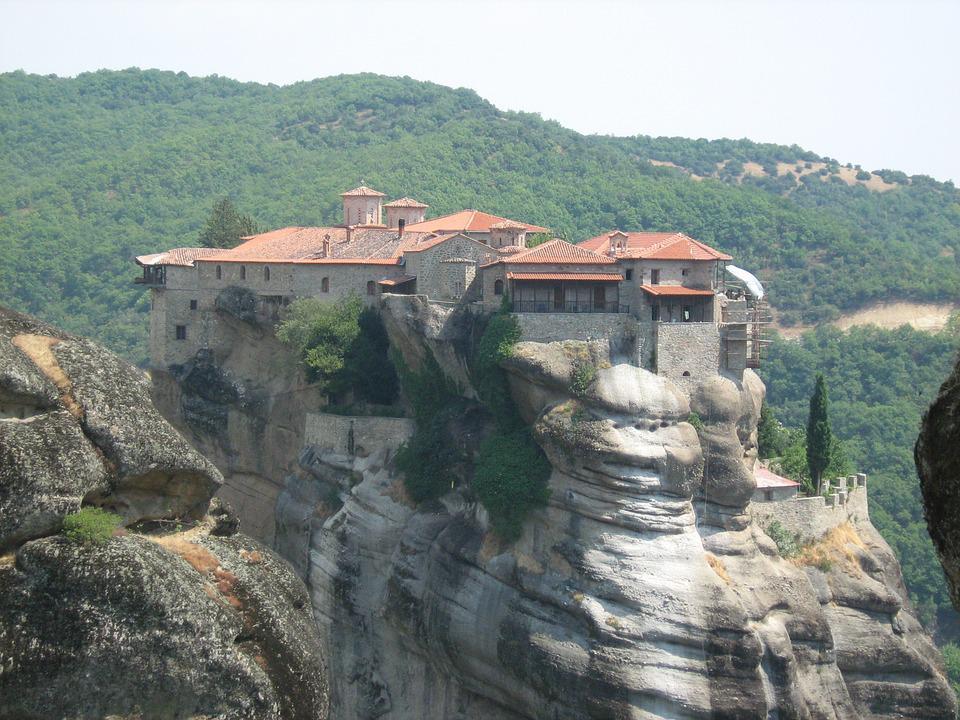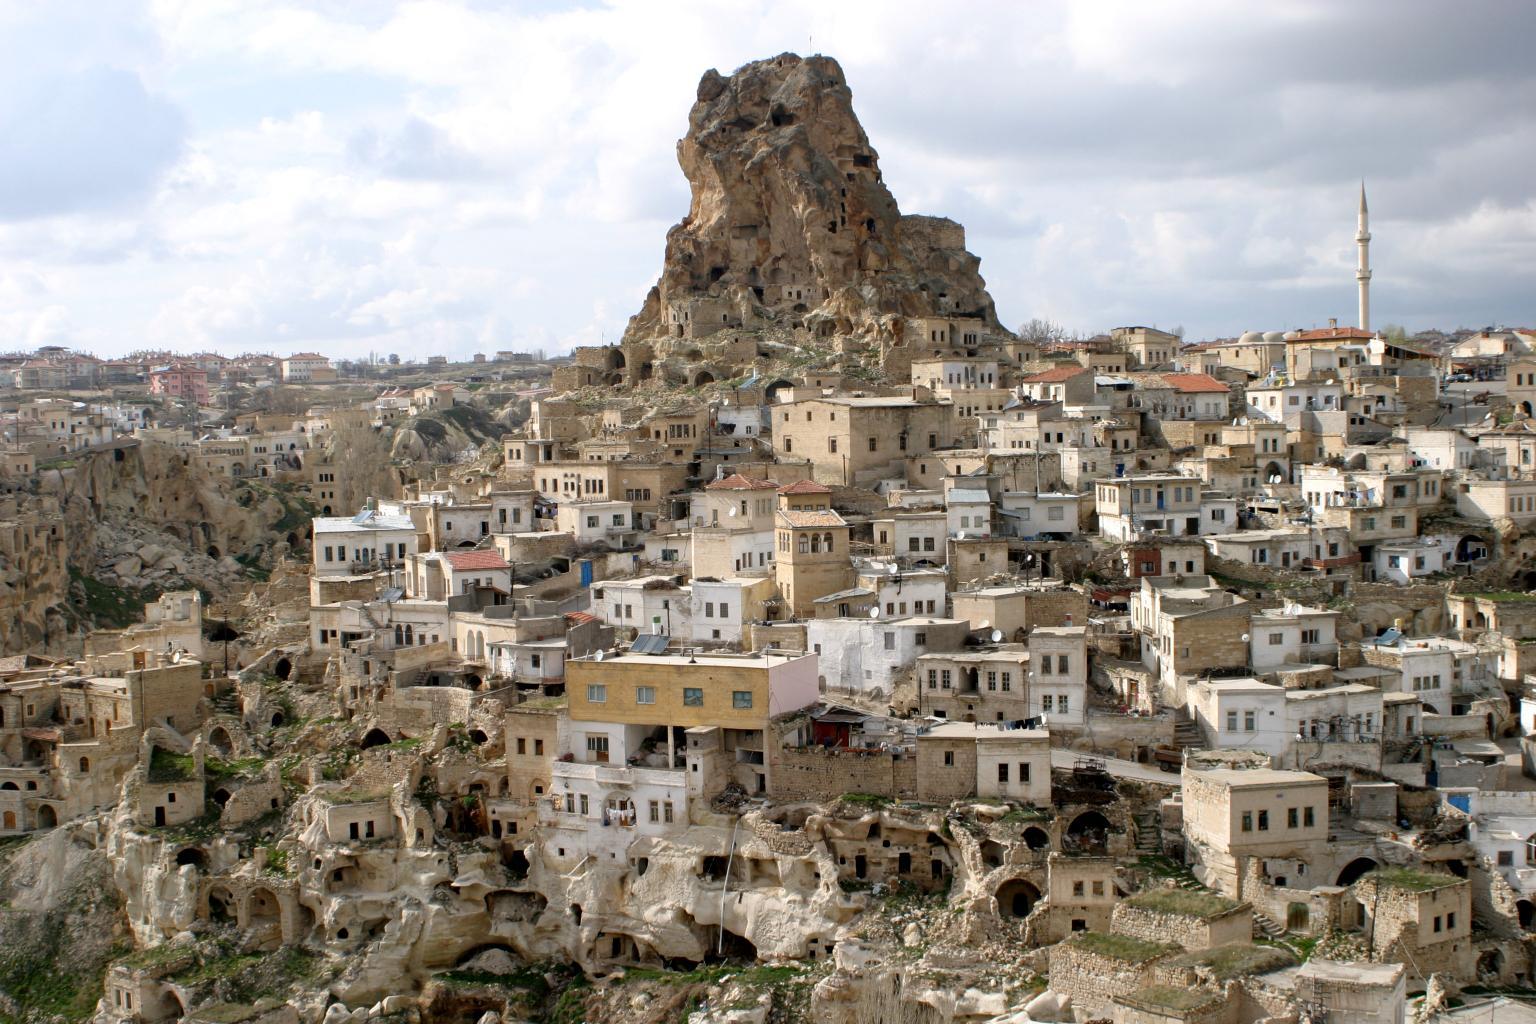The first image is the image on the left, the second image is the image on the right. Given the left and right images, does the statement "All images feature buildings constructed on top of large rocks." hold true? Answer yes or no. No. The first image is the image on the left, the second image is the image on the right. Evaluate the accuracy of this statement regarding the images: "Left image includes bright yellow foliage in front of a steep rocky formation topped with an orangish-roofed building.". Is it true? Answer yes or no. No. 